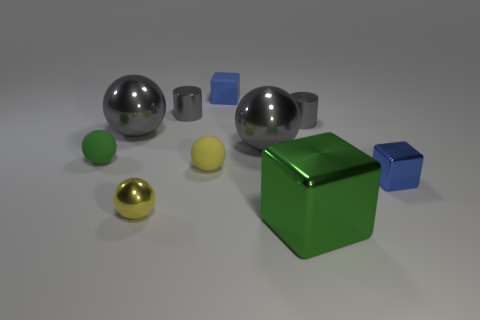There is a gray metallic ball right of the blue cube that is behind the tiny gray thing that is on the right side of the large green shiny cube; what size is it?
Your answer should be very brief. Large. Is there another green ball that has the same material as the tiny green ball?
Ensure brevity in your answer.  No. What shape is the green matte object?
Your answer should be very brief. Sphere. What is the color of the block that is the same material as the green ball?
Keep it short and to the point. Blue. What number of yellow things are cylinders or rubber objects?
Ensure brevity in your answer.  1. Is the number of large gray cylinders greater than the number of gray shiny spheres?
Your response must be concise. No. How many things are either yellow things in front of the blue metal object or tiny metallic cylinders on the left side of the big metal cube?
Provide a succinct answer. 2. The other rubber sphere that is the same size as the green sphere is what color?
Your answer should be very brief. Yellow. Are the large green object and the green ball made of the same material?
Your answer should be compact. No. What material is the green ball behind the object in front of the tiny yellow shiny sphere made of?
Ensure brevity in your answer.  Rubber. 